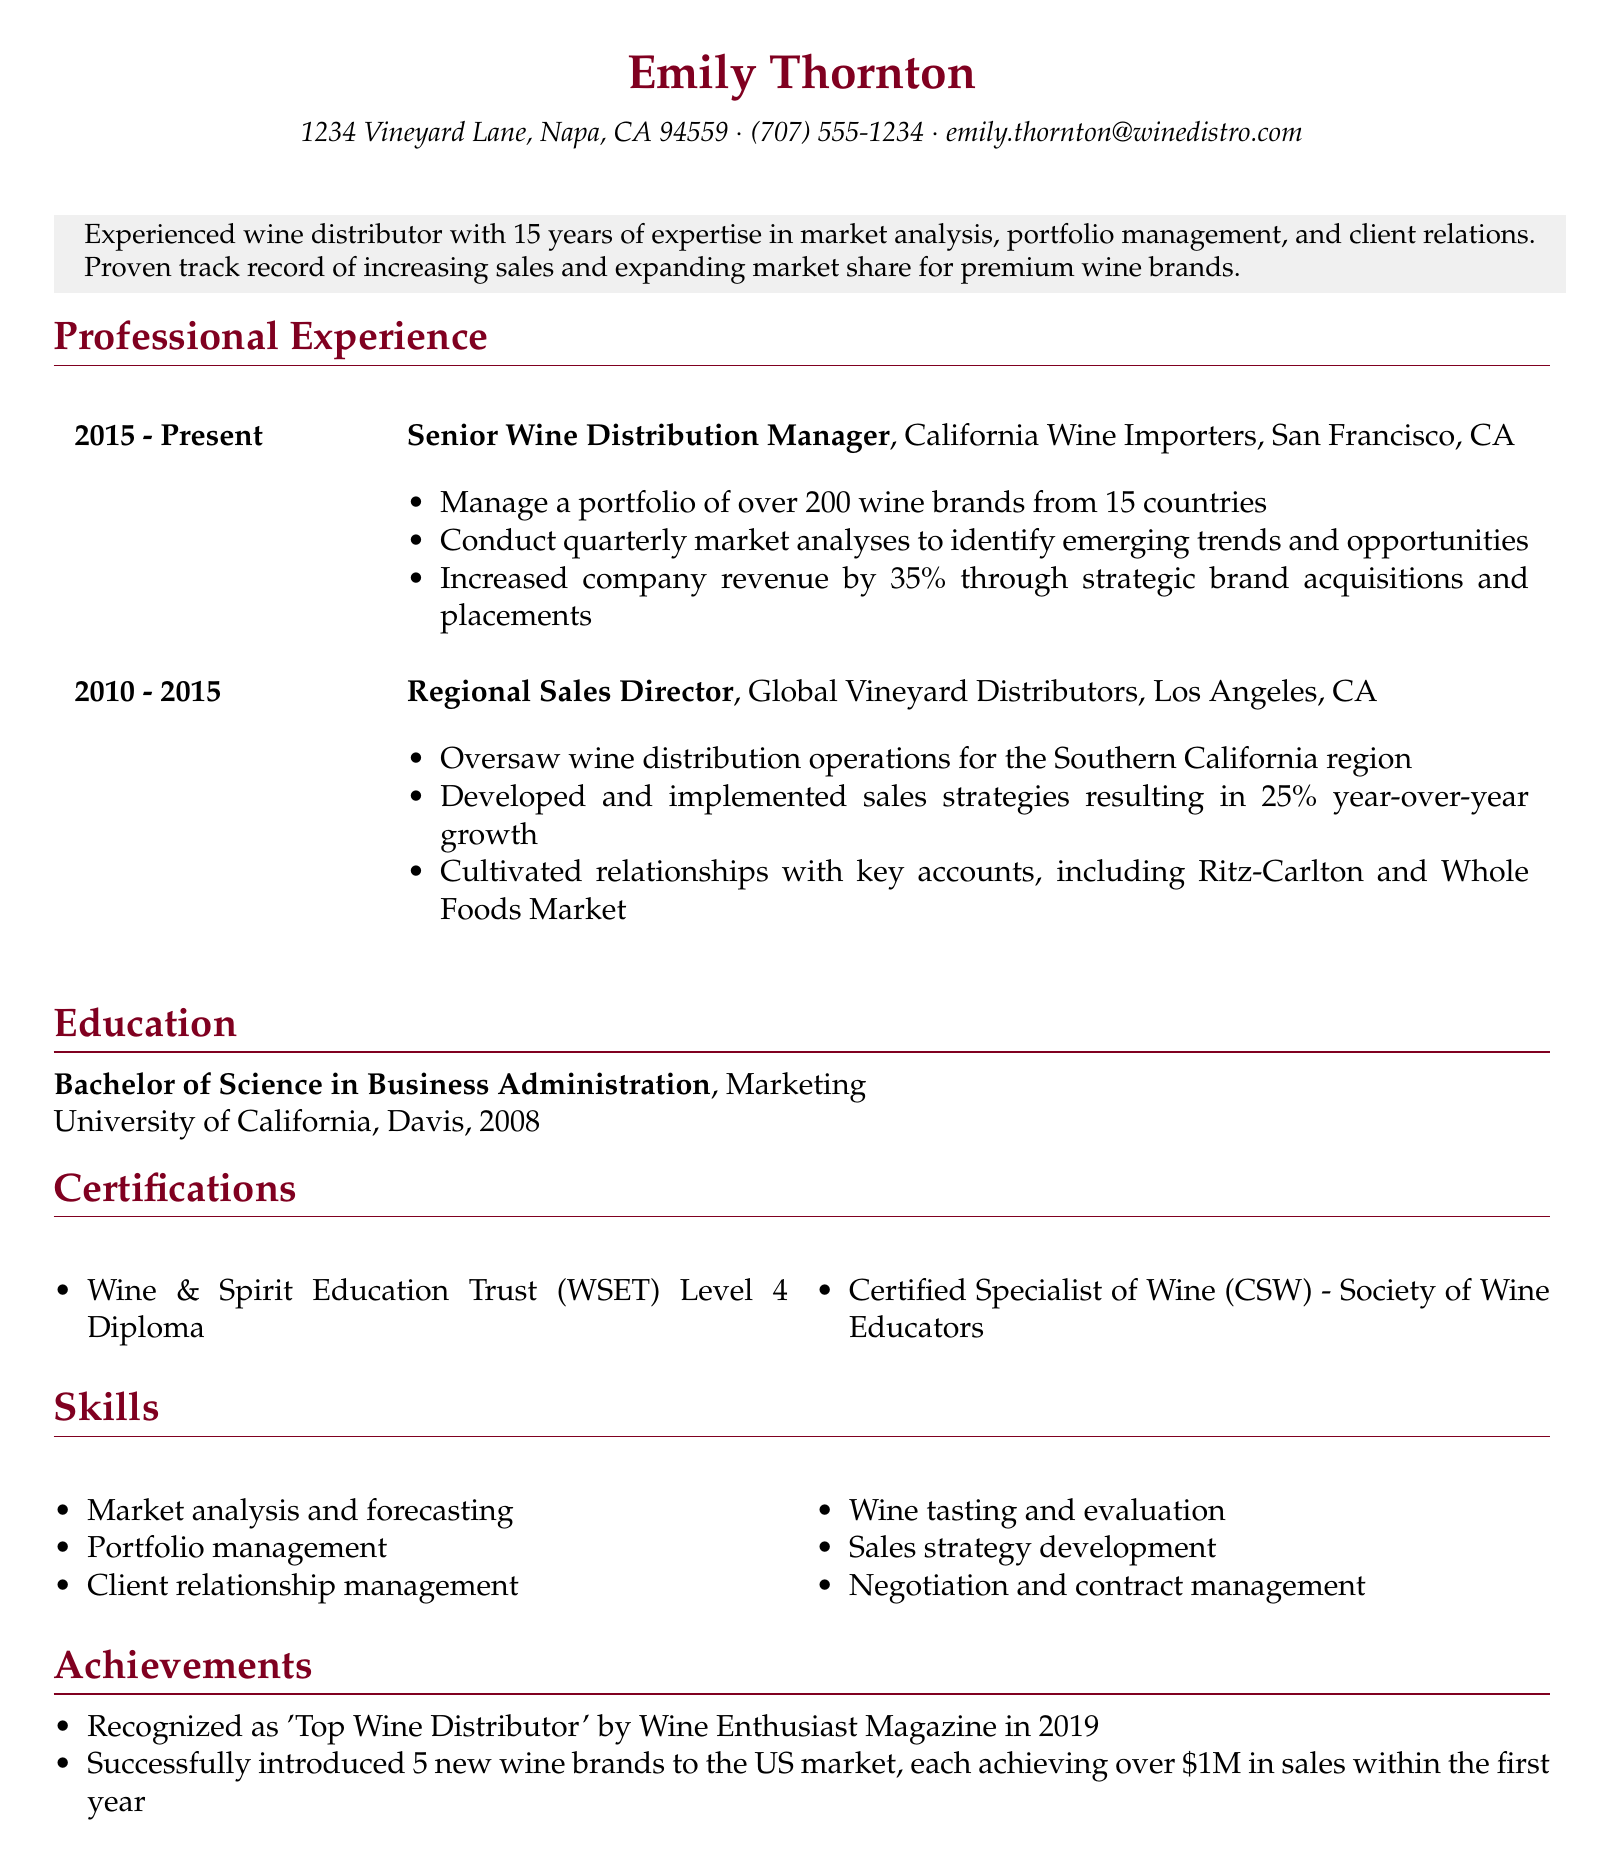what is Emily Thornton's job title? The job title is stated in the work experience section under the current position held by Emily Thornton.
Answer: Senior Wine Distribution Manager how many years of experience does Emily have? The professional summary mentions Emily's years of experience in the wine distribution field.
Answer: 15 years which university did Emily graduate from? The education section specifies the university from which Emily earned her degree.
Answer: University of California, Davis what percentage did the company revenue increase under Emily's management? The responsibilities of her current job detail the percentage increase in company revenue attributed to her work.
Answer: 35% what was one of the key accounts Emily cultivated relationships with? The work experience section lists specific key accounts associated with Emily's former position.
Answer: Ritz-Carlton how many new wine brands did Emily successfully introduce to the US market? The achievements section quantifies the number of new wine brands introduced by Emily.
Answer: 5 what is the name of the certification Emily holds from the Society of Wine Educators? The certifications section provides the specific name of the certification under the respective organization.
Answer: Certified Specialist of Wine in which geographical location did Emily oversee distribution operations as Regional Sales Director? The work experience section identifies the specific region Emily was responsible for as a Regional Sales Director.
Answer: Southern California which magazine recognized Emily as the 'Top Wine Distributor'? The achievements section indicates the publication that acknowledged Emily's success in the industry.
Answer: Wine Enthusiast Magazine 